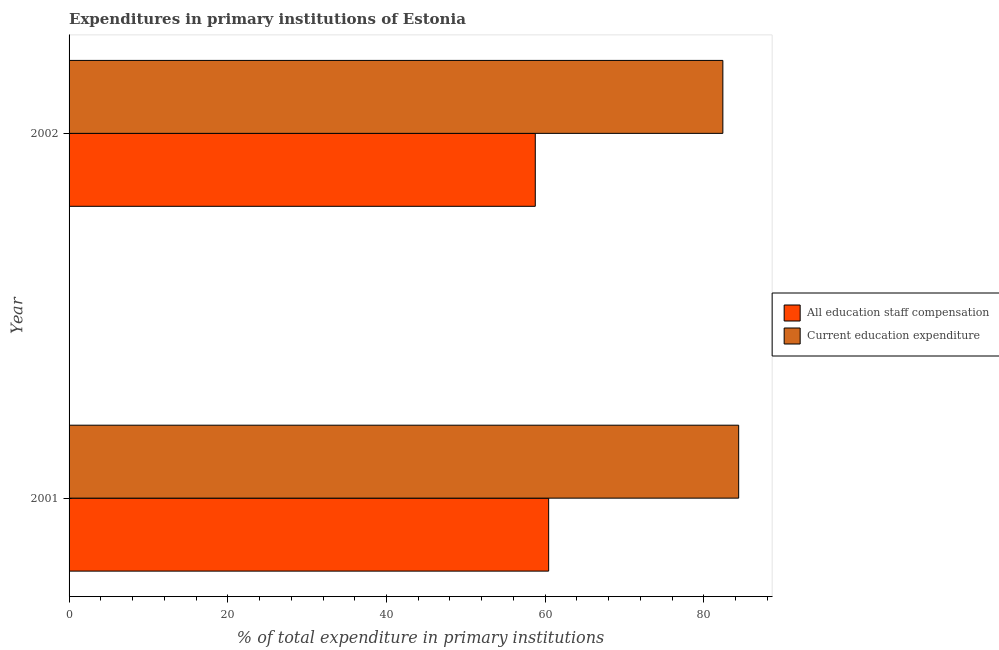Are the number of bars on each tick of the Y-axis equal?
Keep it short and to the point. Yes. How many bars are there on the 2nd tick from the top?
Keep it short and to the point. 2. How many bars are there on the 1st tick from the bottom?
Provide a short and direct response. 2. What is the label of the 2nd group of bars from the top?
Ensure brevity in your answer.  2001. What is the expenditure in education in 2002?
Provide a short and direct response. 82.39. Across all years, what is the maximum expenditure in staff compensation?
Offer a very short reply. 60.44. Across all years, what is the minimum expenditure in staff compensation?
Give a very brief answer. 58.75. What is the total expenditure in education in the graph?
Provide a short and direct response. 166.77. What is the difference between the expenditure in staff compensation in 2001 and that in 2002?
Provide a succinct answer. 1.69. What is the difference between the expenditure in staff compensation in 2002 and the expenditure in education in 2001?
Your answer should be very brief. -25.63. What is the average expenditure in education per year?
Your response must be concise. 83.38. In the year 2001, what is the difference between the expenditure in education and expenditure in staff compensation?
Your answer should be very brief. 23.94. Is the expenditure in education in 2001 less than that in 2002?
Ensure brevity in your answer.  No. In how many years, is the expenditure in staff compensation greater than the average expenditure in staff compensation taken over all years?
Offer a very short reply. 1. What does the 2nd bar from the top in 2002 represents?
Ensure brevity in your answer.  All education staff compensation. What does the 1st bar from the bottom in 2002 represents?
Offer a very short reply. All education staff compensation. How many bars are there?
Keep it short and to the point. 4. Are all the bars in the graph horizontal?
Offer a terse response. Yes. What is the difference between two consecutive major ticks on the X-axis?
Offer a terse response. 20. Does the graph contain any zero values?
Your response must be concise. No. How many legend labels are there?
Give a very brief answer. 2. What is the title of the graph?
Offer a very short reply. Expenditures in primary institutions of Estonia. What is the label or title of the X-axis?
Give a very brief answer. % of total expenditure in primary institutions. What is the % of total expenditure in primary institutions of All education staff compensation in 2001?
Ensure brevity in your answer.  60.44. What is the % of total expenditure in primary institutions in Current education expenditure in 2001?
Offer a terse response. 84.38. What is the % of total expenditure in primary institutions of All education staff compensation in 2002?
Keep it short and to the point. 58.75. What is the % of total expenditure in primary institutions of Current education expenditure in 2002?
Make the answer very short. 82.39. Across all years, what is the maximum % of total expenditure in primary institutions of All education staff compensation?
Provide a succinct answer. 60.44. Across all years, what is the maximum % of total expenditure in primary institutions in Current education expenditure?
Provide a short and direct response. 84.38. Across all years, what is the minimum % of total expenditure in primary institutions in All education staff compensation?
Your answer should be very brief. 58.75. Across all years, what is the minimum % of total expenditure in primary institutions in Current education expenditure?
Your answer should be very brief. 82.39. What is the total % of total expenditure in primary institutions in All education staff compensation in the graph?
Your response must be concise. 119.19. What is the total % of total expenditure in primary institutions of Current education expenditure in the graph?
Offer a very short reply. 166.77. What is the difference between the % of total expenditure in primary institutions of All education staff compensation in 2001 and that in 2002?
Provide a succinct answer. 1.69. What is the difference between the % of total expenditure in primary institutions in Current education expenditure in 2001 and that in 2002?
Make the answer very short. 1.99. What is the difference between the % of total expenditure in primary institutions of All education staff compensation in 2001 and the % of total expenditure in primary institutions of Current education expenditure in 2002?
Your answer should be very brief. -21.95. What is the average % of total expenditure in primary institutions of All education staff compensation per year?
Provide a succinct answer. 59.59. What is the average % of total expenditure in primary institutions of Current education expenditure per year?
Your response must be concise. 83.38. In the year 2001, what is the difference between the % of total expenditure in primary institutions of All education staff compensation and % of total expenditure in primary institutions of Current education expenditure?
Provide a succinct answer. -23.94. In the year 2002, what is the difference between the % of total expenditure in primary institutions in All education staff compensation and % of total expenditure in primary institutions in Current education expenditure?
Provide a short and direct response. -23.64. What is the ratio of the % of total expenditure in primary institutions in All education staff compensation in 2001 to that in 2002?
Offer a very short reply. 1.03. What is the ratio of the % of total expenditure in primary institutions of Current education expenditure in 2001 to that in 2002?
Provide a succinct answer. 1.02. What is the difference between the highest and the second highest % of total expenditure in primary institutions in All education staff compensation?
Provide a succinct answer. 1.69. What is the difference between the highest and the second highest % of total expenditure in primary institutions of Current education expenditure?
Make the answer very short. 1.99. What is the difference between the highest and the lowest % of total expenditure in primary institutions of All education staff compensation?
Offer a terse response. 1.69. What is the difference between the highest and the lowest % of total expenditure in primary institutions in Current education expenditure?
Your response must be concise. 1.99. 